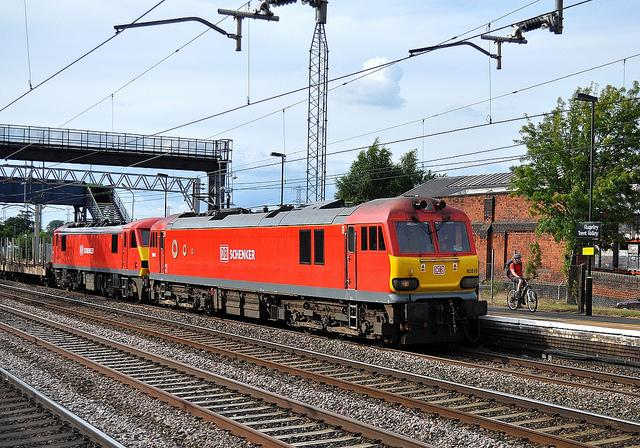Why has the cyclist covered his head? Please explain your reasoning. safety. Riders must wear a head covering in case they fall and hit their heads on a rock. 